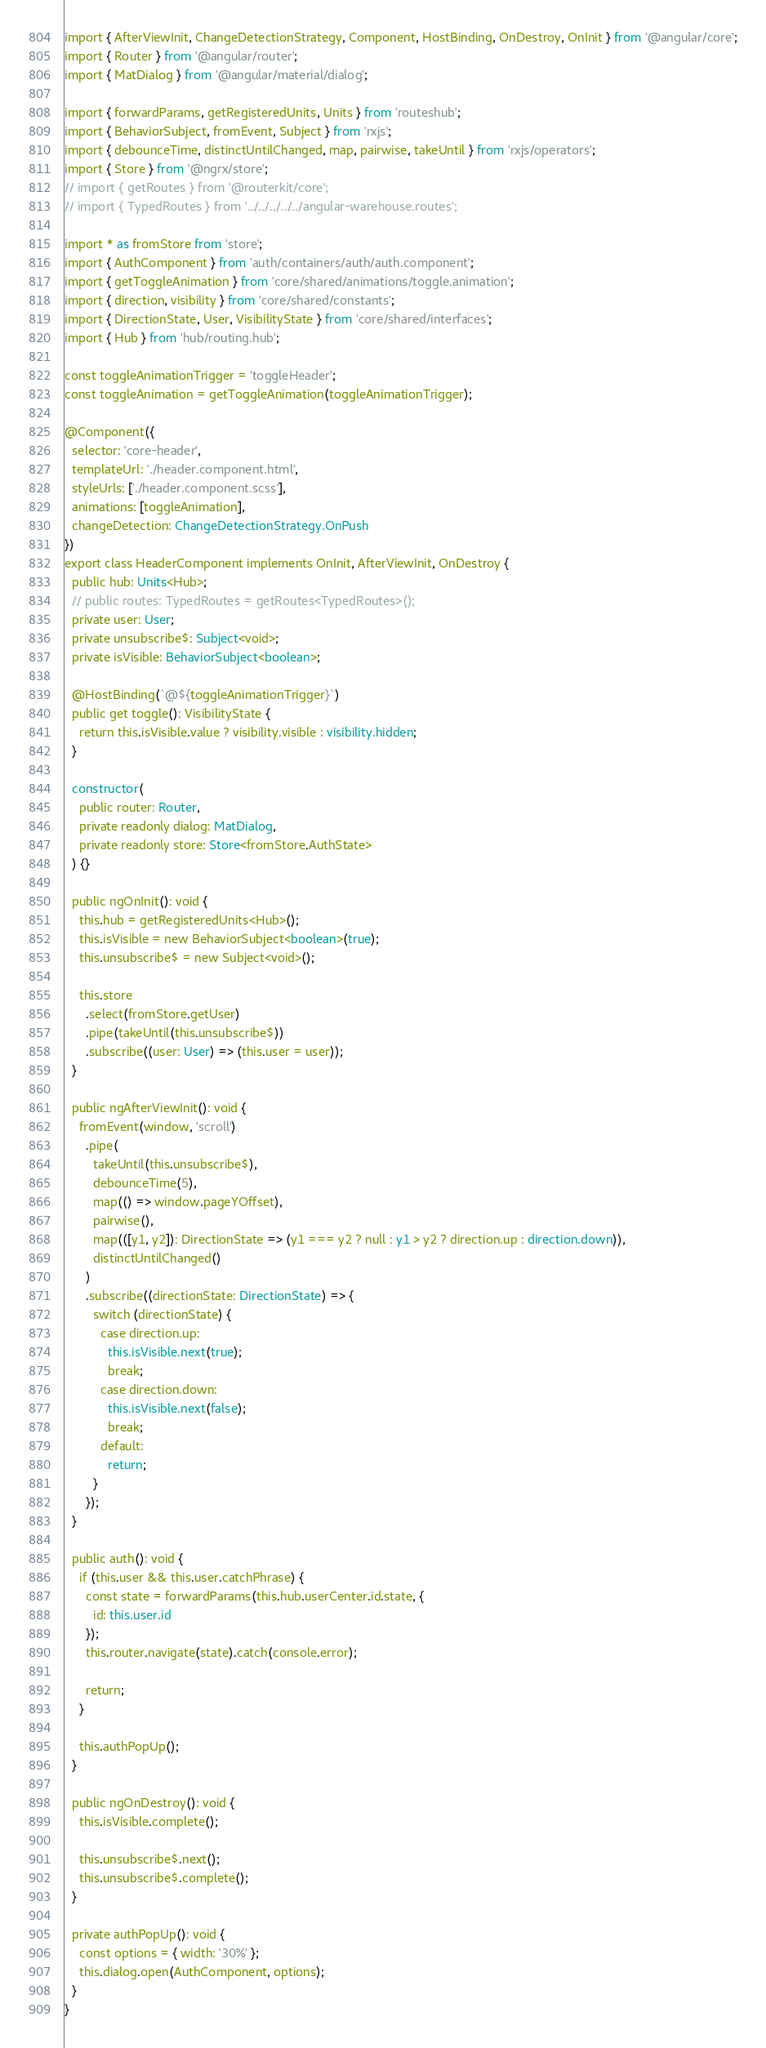<code> <loc_0><loc_0><loc_500><loc_500><_TypeScript_>import { AfterViewInit, ChangeDetectionStrategy, Component, HostBinding, OnDestroy, OnInit } from '@angular/core';
import { Router } from '@angular/router';
import { MatDialog } from '@angular/material/dialog';

import { forwardParams, getRegisteredUnits, Units } from 'routeshub';
import { BehaviorSubject, fromEvent, Subject } from 'rxjs';
import { debounceTime, distinctUntilChanged, map, pairwise, takeUntil } from 'rxjs/operators';
import { Store } from '@ngrx/store';
// import { getRoutes } from '@routerkit/core';
// import { TypedRoutes } from '../../../../../angular-warehouse.routes';

import * as fromStore from 'store';
import { AuthComponent } from 'auth/containers/auth/auth.component';
import { getToggleAnimation } from 'core/shared/animations/toggle.animation';
import { direction, visibility } from 'core/shared/constants';
import { DirectionState, User, VisibilityState } from 'core/shared/interfaces';
import { Hub } from 'hub/routing.hub';

const toggleAnimationTrigger = 'toggleHeader';
const toggleAnimation = getToggleAnimation(toggleAnimationTrigger);

@Component({
  selector: 'core-header',
  templateUrl: './header.component.html',
  styleUrls: ['./header.component.scss'],
  animations: [toggleAnimation],
  changeDetection: ChangeDetectionStrategy.OnPush
})
export class HeaderComponent implements OnInit, AfterViewInit, OnDestroy {
  public hub: Units<Hub>;
  // public routes: TypedRoutes = getRoutes<TypedRoutes>();
  private user: User;
  private unsubscribe$: Subject<void>;
  private isVisible: BehaviorSubject<boolean>;

  @HostBinding(`@${toggleAnimationTrigger}`)
  public get toggle(): VisibilityState {
    return this.isVisible.value ? visibility.visible : visibility.hidden;
  }

  constructor(
    public router: Router,
    private readonly dialog: MatDialog,
    private readonly store: Store<fromStore.AuthState>
  ) {}

  public ngOnInit(): void {
    this.hub = getRegisteredUnits<Hub>();
    this.isVisible = new BehaviorSubject<boolean>(true);
    this.unsubscribe$ = new Subject<void>();

    this.store
      .select(fromStore.getUser)
      .pipe(takeUntil(this.unsubscribe$))
      .subscribe((user: User) => (this.user = user));
  }

  public ngAfterViewInit(): void {
    fromEvent(window, 'scroll')
      .pipe(
        takeUntil(this.unsubscribe$),
        debounceTime(5),
        map(() => window.pageYOffset),
        pairwise(),
        map(([y1, y2]): DirectionState => (y1 === y2 ? null : y1 > y2 ? direction.up : direction.down)),
        distinctUntilChanged()
      )
      .subscribe((directionState: DirectionState) => {
        switch (directionState) {
          case direction.up:
            this.isVisible.next(true);
            break;
          case direction.down:
            this.isVisible.next(false);
            break;
          default:
            return;
        }
      });
  }

  public auth(): void {
    if (this.user && this.user.catchPhrase) {
      const state = forwardParams(this.hub.userCenter.id.state, {
        id: this.user.id
      });
      this.router.navigate(state).catch(console.error);

      return;
    }

    this.authPopUp();
  }

  public ngOnDestroy(): void {
    this.isVisible.complete();

    this.unsubscribe$.next();
    this.unsubscribe$.complete();
  }

  private authPopUp(): void {
    const options = { width: '30%' };
    this.dialog.open(AuthComponent, options);
  }
}
</code> 